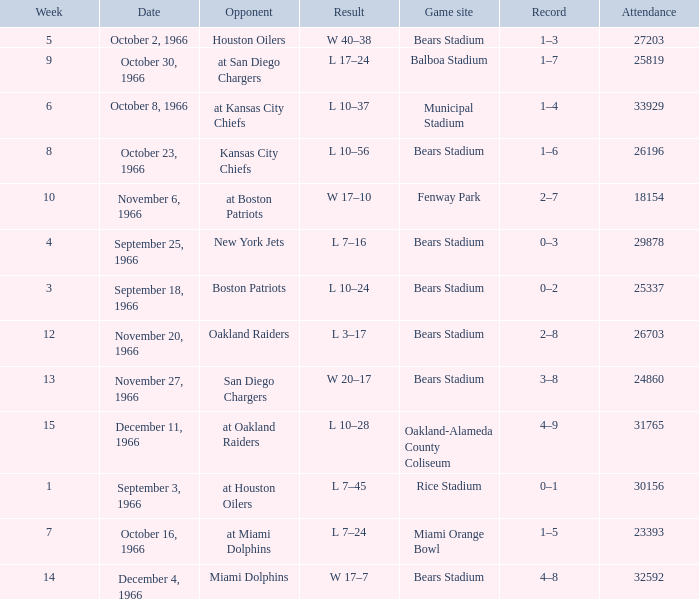What was the date of the game when the opponent was the Miami Dolphins? December 4, 1966. 